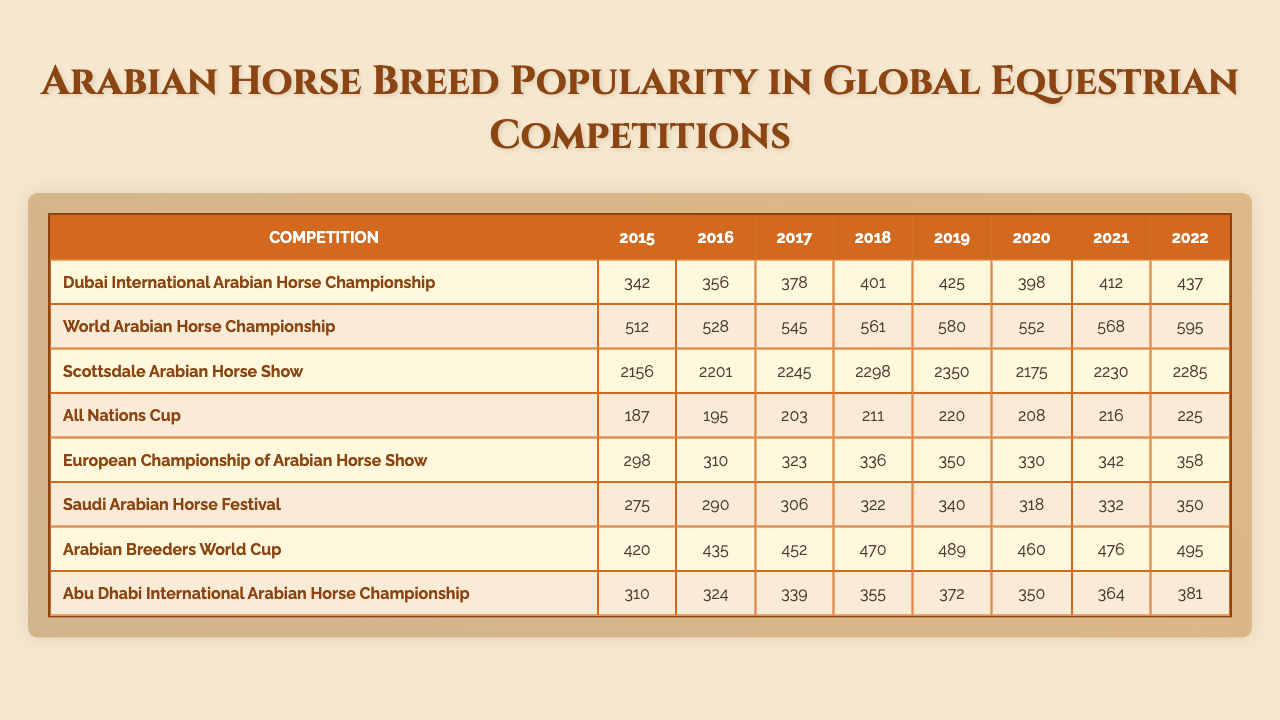What is the total number of entries at the Scottsdale Arabian Horse Show in 2019? Referring to the table, the number of entries for the Scottsdale Arabian Horse Show in 2019 is 2350.
Answer: 2350 Which competition had the highest number of entries in 2022? In 2022, the entries for each competition are: Dubai International Arabian Horse Championship (437), World Arabian Horse Championship (595), Scottsdale Arabian Horse Show (2285), All Nations Cup (225), European Championship of Arabian Horse Show (358), Saudi Arabian Horse Festival (350), Arabian Breeders World Cup (495), and Abu Dhabi International Arabian Horse Championship (381). The highest is 2285 at the Scottsdale Arabian Horse Show.
Answer: 2285 What is the average number of entries across all competitions in 2021? First, sum the entries for 2021: (412 + 568 + 2230 + 216 + 342 + 332 + 476 + 364) = 3520. There are 8 competitions, so the average is 3520 / 8 = 440.
Answer: 440 Did the number of entries in the Dubai International Arabian Horse Championship increase every year from 2015 to 2022? The entries for the Dubai International Arabian Horse Championship over the years are as follows: 342 (2015), 356 (2016), 378 (2017), 401 (2018), 425 (2019), 398 (2020), 412 (2021), and 437 (2022). The entries increased from 2015 to 2019, but there was a decrease from 2019 to 2020, so it did not increase every year.
Answer: No What was the difference in entries between the World Arabian Horse Championship and the Saudi Arabian Horse Festival in 2020? In 2020, the World Arabian Horse Championship had 552 entries, and the Saudi Arabian Horse Festival had 318. The difference is calculated as 552 - 318 = 234.
Answer: 234 What is the trend in entries for the Arabian Breeders World Cup from 2015 to 2022? The entries were: 420 (2015), 435 (2016), 452 (2017), 470 (2018), 489 (2019), 460 (2020), 476 (2021), and 495 (2022). We see the entries rising from 2015 to 2019, a slight decline in 2020, and then a general increase until 2022.
Answer: Increasing with a decline in 2020 Which competition had the lowest entry total in 2016? In 2016, the number of entries for each competition are: Dubai International Arabian Horse Championship (356), World Arabian Horse Championship (528), Scottsdale Arabian Horse Show (2201), All Nations Cup (195), European Championship of Arabian Horse Show (310), Saudi Arabian Horse Festival (290), Arabian Breeders World Cup (435), and Abu Dhabi International Arabian Horse Championship (324). The lowest total is 195 from the All Nations Cup.
Answer: All Nations Cup What was the year with the highest overall entries total, and what was that total? To find the total for each year, sum the entries across all competitions: 342 + 512 + 2156 + 187 + 298 + 275 + 420 + 310 = 4390 for 2015, 356 + 528 + 2201 + 195 + 310 + 290 + 435 + 324 = 4345 for 2016, and similarly for the other years. After calculating, 2017 had the highest total of 4609.
Answer: 2017, 4609 Did the entries at the European Championship of Arabian Horse Show show consistent growth each year from 2015 to 2022? The entries are: 298 (2015), 310 (2016), 323 (2017), 336 (2018), 350 (2019), 330 (2020), 342 (2021), and 358 (2022). The data shows growth but also a decline in 2020 (from 350 to 330). Hence, it was not consistent growth.
Answer: No 